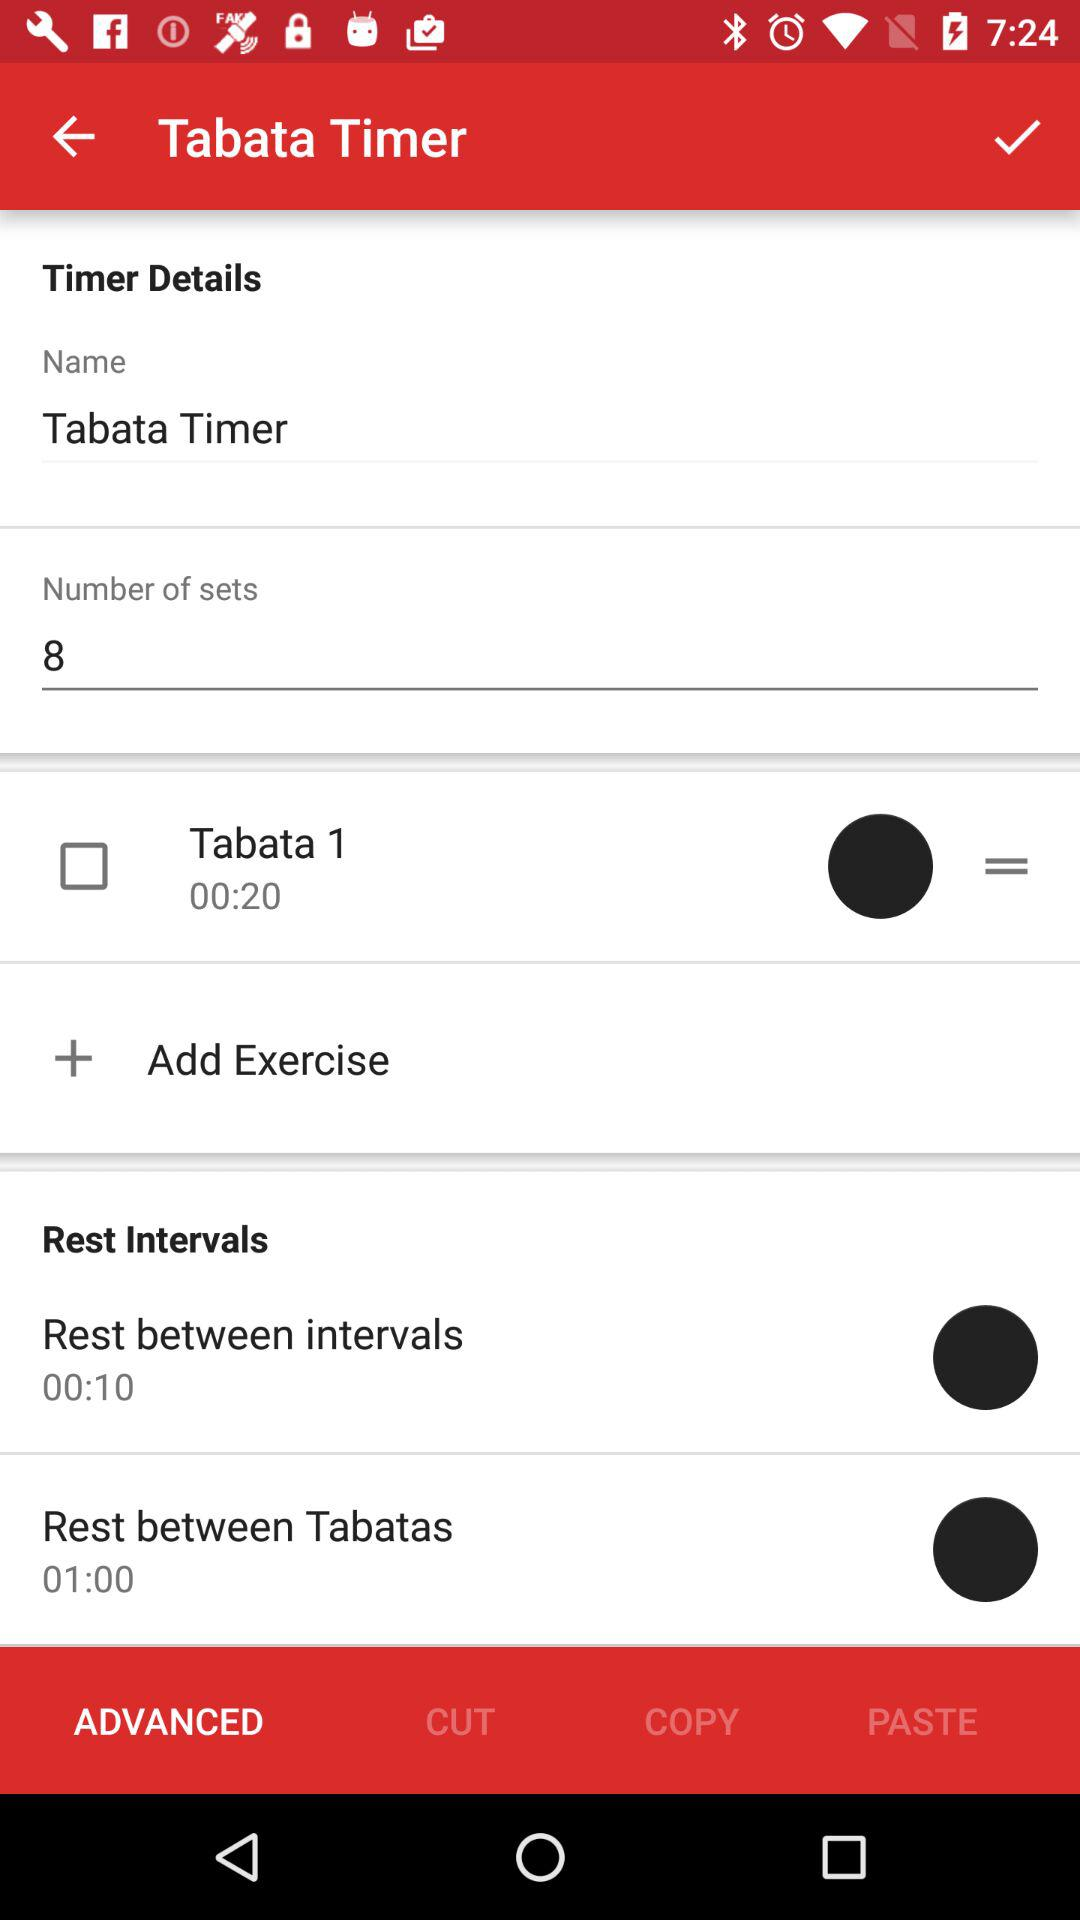What is the name given on the screen? The given name is Tabata Timer. 